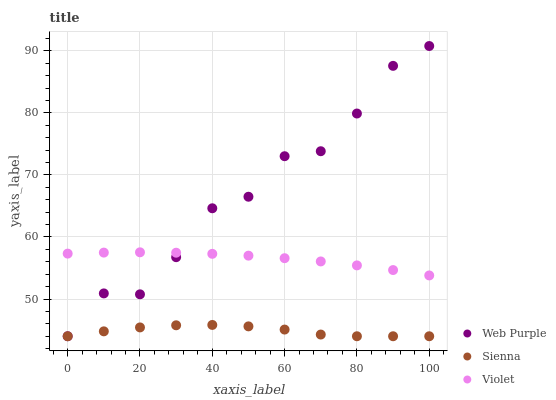Does Sienna have the minimum area under the curve?
Answer yes or no. Yes. Does Web Purple have the maximum area under the curve?
Answer yes or no. Yes. Does Violet have the minimum area under the curve?
Answer yes or no. No. Does Violet have the maximum area under the curve?
Answer yes or no. No. Is Violet the smoothest?
Answer yes or no. Yes. Is Web Purple the roughest?
Answer yes or no. Yes. Is Web Purple the smoothest?
Answer yes or no. No. Is Violet the roughest?
Answer yes or no. No. Does Sienna have the lowest value?
Answer yes or no. Yes. Does Violet have the lowest value?
Answer yes or no. No. Does Web Purple have the highest value?
Answer yes or no. Yes. Does Violet have the highest value?
Answer yes or no. No. Is Sienna less than Violet?
Answer yes or no. Yes. Is Violet greater than Sienna?
Answer yes or no. Yes. Does Sienna intersect Web Purple?
Answer yes or no. Yes. Is Sienna less than Web Purple?
Answer yes or no. No. Is Sienna greater than Web Purple?
Answer yes or no. No. Does Sienna intersect Violet?
Answer yes or no. No. 